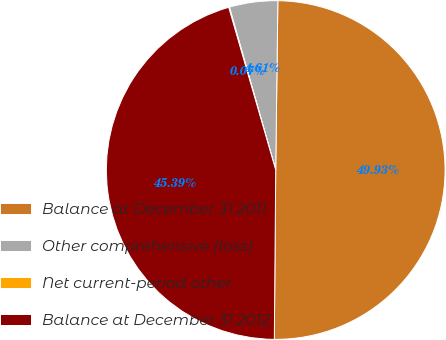Convert chart. <chart><loc_0><loc_0><loc_500><loc_500><pie_chart><fcel>Balance at December 31 2011<fcel>Other comprehensive (loss)<fcel>Net current-period other<fcel>Balance at December 31 2012<nl><fcel>49.93%<fcel>4.61%<fcel>0.07%<fcel>45.39%<nl></chart> 